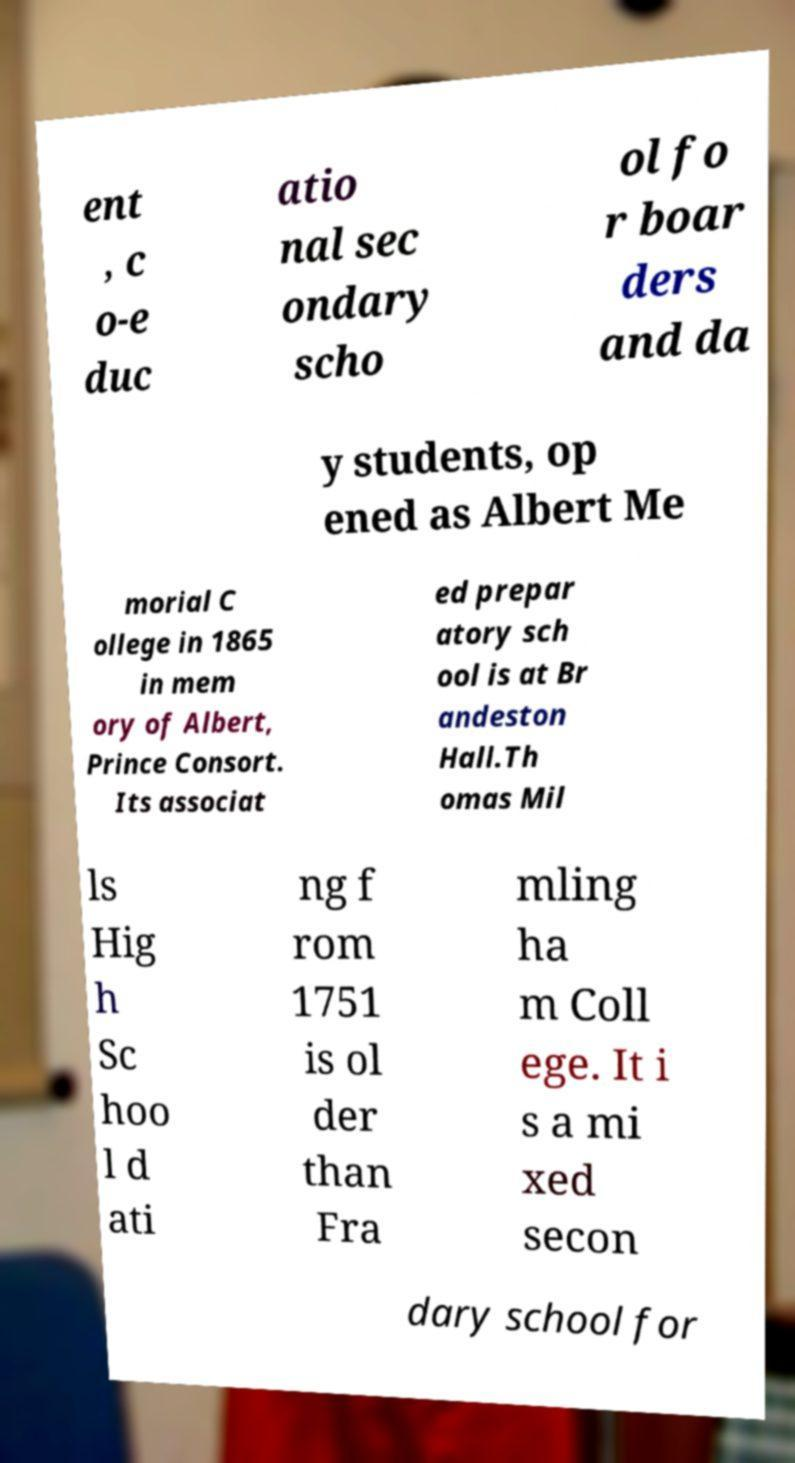Can you accurately transcribe the text from the provided image for me? ent , c o-e duc atio nal sec ondary scho ol fo r boar ders and da y students, op ened as Albert Me morial C ollege in 1865 in mem ory of Albert, Prince Consort. Its associat ed prepar atory sch ool is at Br andeston Hall.Th omas Mil ls Hig h Sc hoo l d ati ng f rom 1751 is ol der than Fra mling ha m Coll ege. It i s a mi xed secon dary school for 